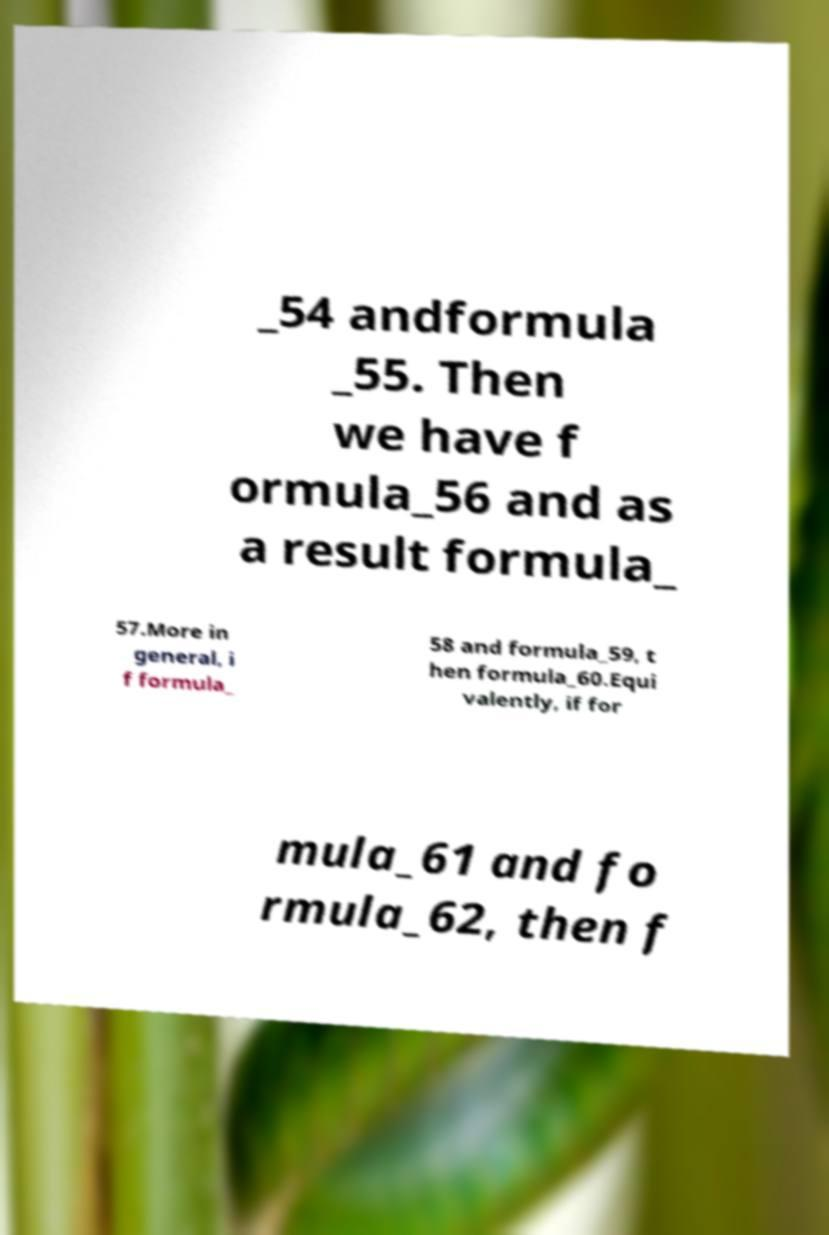Can you accurately transcribe the text from the provided image for me? _54 andformula _55. Then we have f ormula_56 and as a result formula_ 57.More in general, i f formula_ 58 and formula_59, t hen formula_60.Equi valently, if for mula_61 and fo rmula_62, then f 